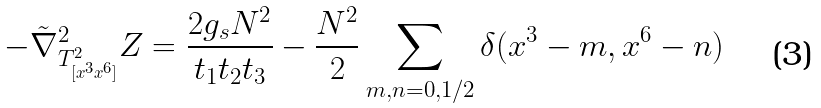<formula> <loc_0><loc_0><loc_500><loc_500>- \tilde { \nabla } ^ { 2 } _ { T ^ { 2 } _ { [ x ^ { 3 } x ^ { 6 } ] } } Z = \frac { 2 g _ { s } N ^ { 2 } } { t _ { 1 } t _ { 2 } t _ { 3 } } - \frac { N ^ { 2 } } { 2 } \sum _ { m , n = 0 , 1 / 2 } \delta ( x ^ { 3 } - m , x ^ { 6 } - n )</formula> 